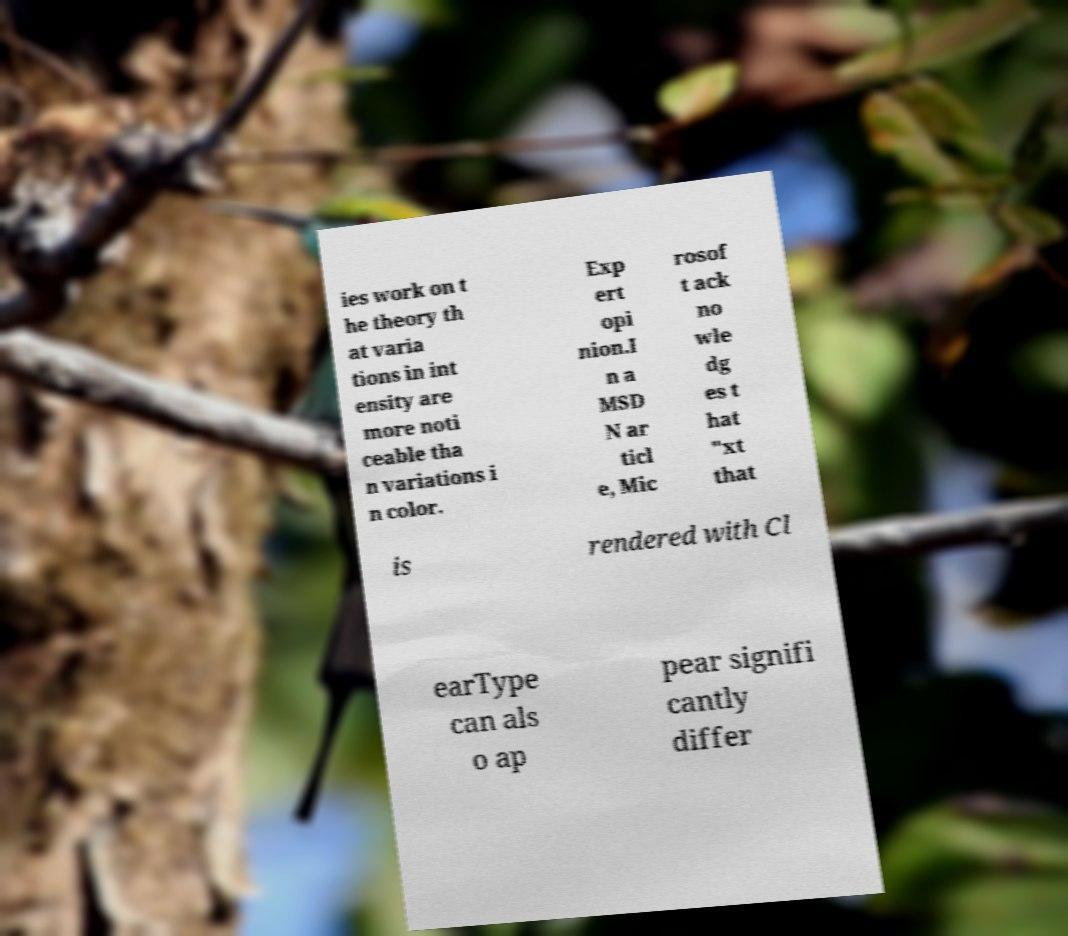Could you assist in decoding the text presented in this image and type it out clearly? ies work on t he theory th at varia tions in int ensity are more noti ceable tha n variations i n color. Exp ert opi nion.I n a MSD N ar ticl e, Mic rosof t ack no wle dg es t hat "xt that is rendered with Cl earType can als o ap pear signifi cantly differ 